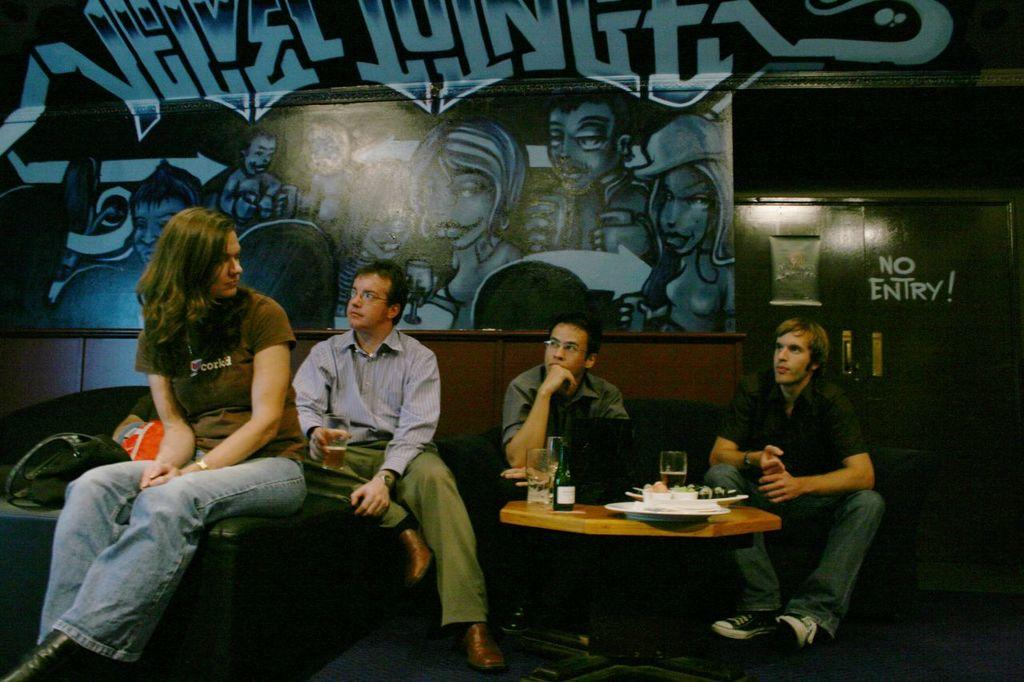How many people are present in the image? There are four persons in the image. What type of furniture is visible in the image? There is a bed, chairs, and a table in the image. What items can be seen on the table? There are bottles, glasses, and a plate on the table. What type of current is flowing through the wren in the image? There is no wren present in the image, and therefore no current can be flowing through it. 